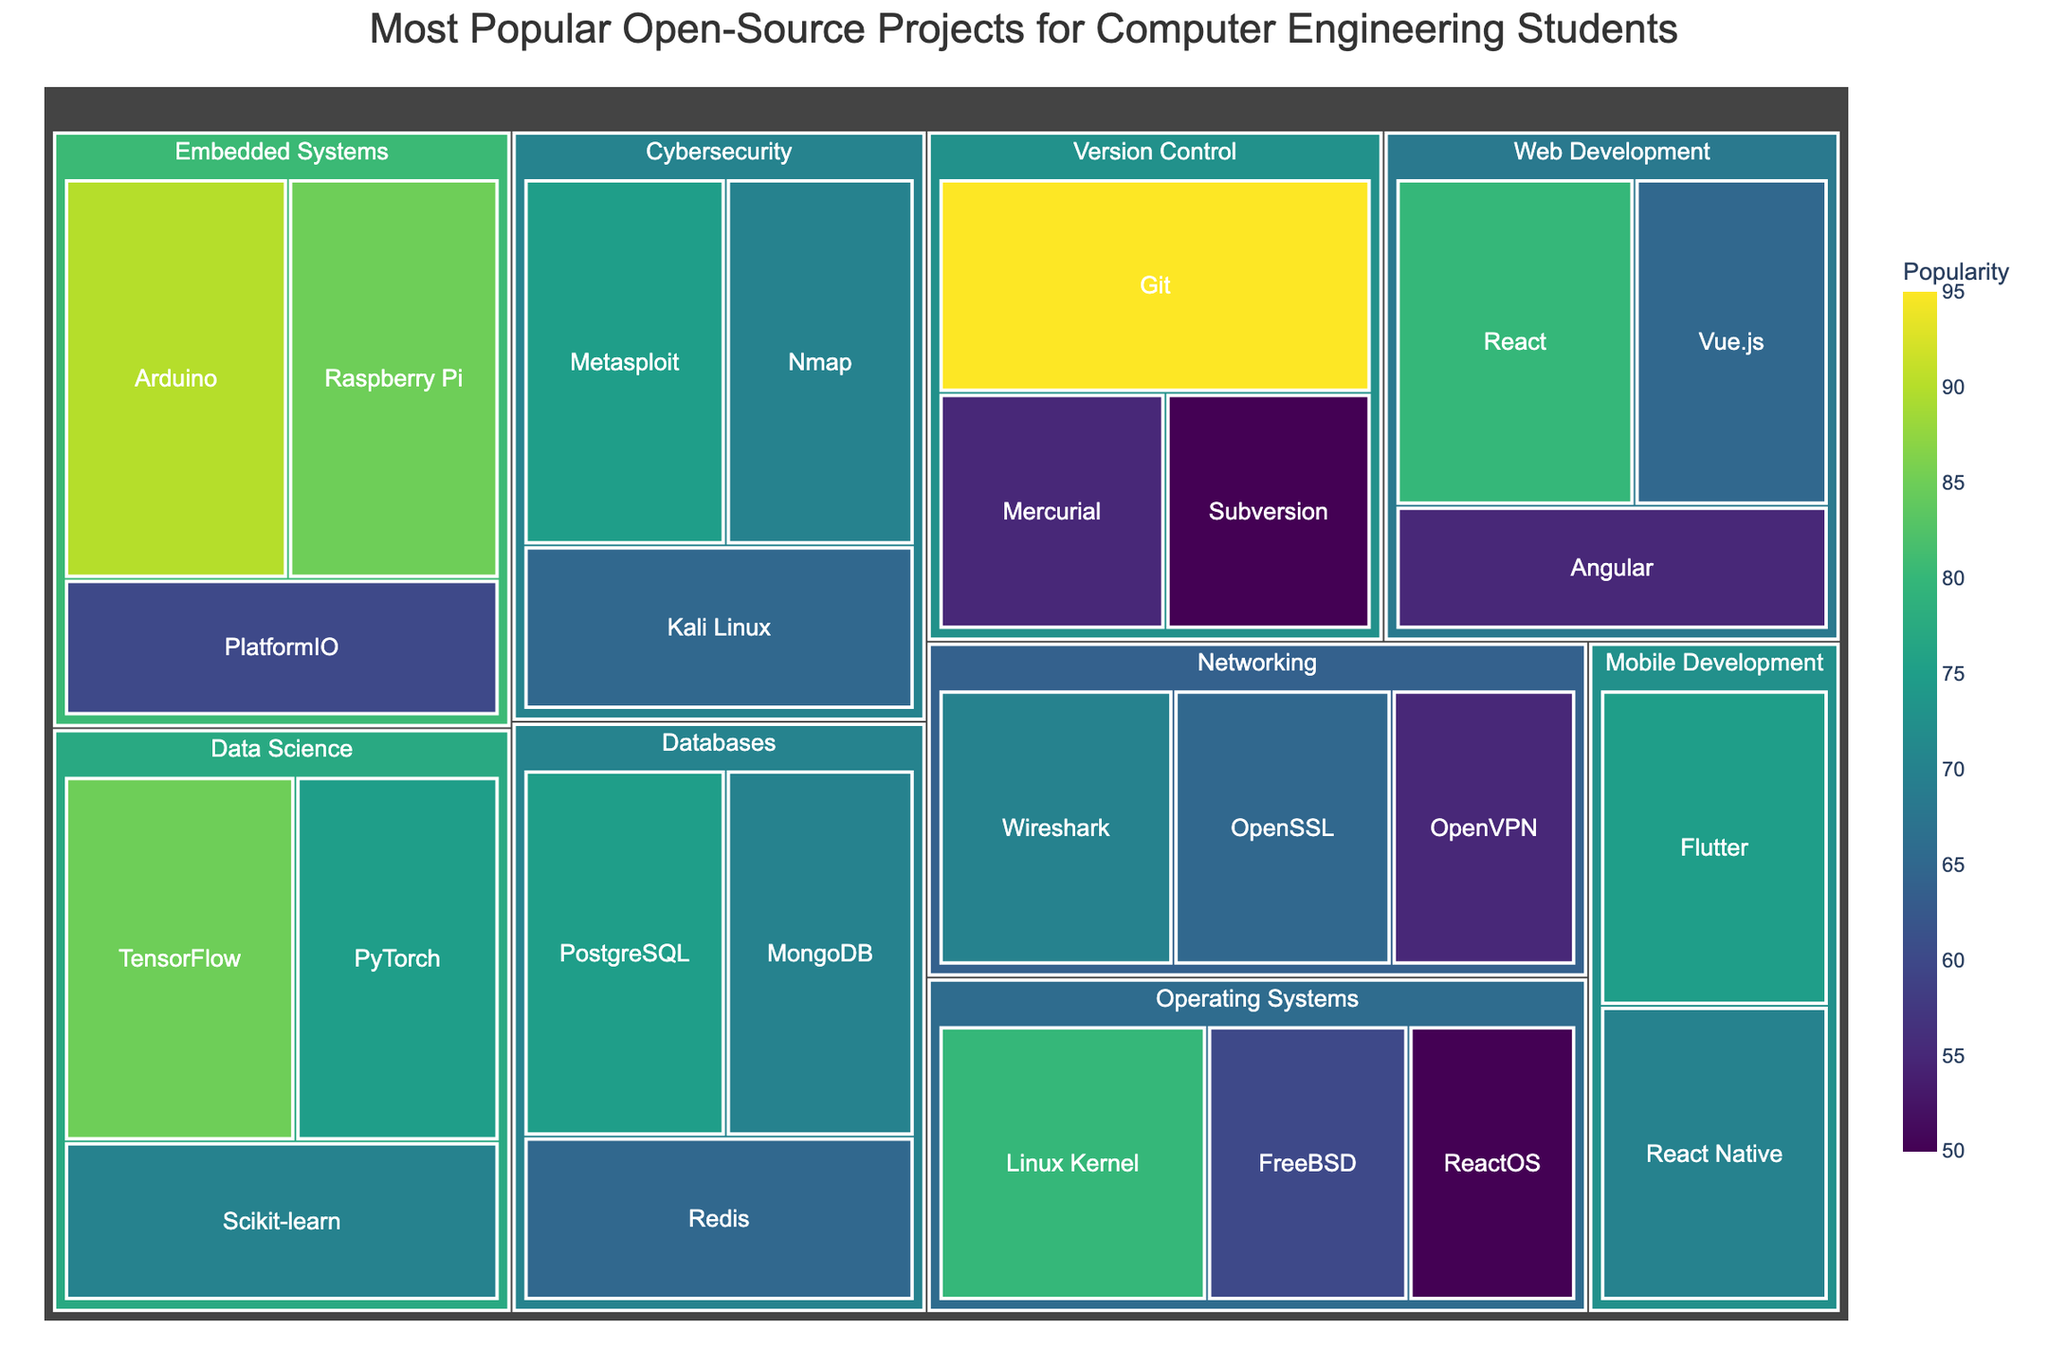What's the most popular project in the 'Web Development' category? The 'Web Development' category contains React, Vue.js, and Angular. By checking their popularity values, React has the highest popularity with a value of 80.
Answer: React Compare the popularity of TensorFlow and PyTorch in the 'Data Science' category. Which one is more popular and by how much? In the 'Data Science' category, TensorFlow has a popularity of 85 and PyTorch has a popularity of 75. TensorFlow is more popular by 10 points.
Answer: TensorFlow by 10 points Identify the least popular project in the 'Version Control' category and provide its popularity value. The 'Version Control' category includes Git, Mercurial, and Subversion. By examining their popularity values, Subversion has the lowest with a value of 50.
Answer: Subversion, 50 What is the combined popularity of 'React Native' and 'Kali Linux'? React Native has a popularity of 70 and Kali Linux has a popularity of 65. Their combined popularity is 70 + 65 = 135.
Answer: 135 How does the popularity of the Linux Kernel compare to Flutter in their respective categories? The Linux Kernel in the 'Operating Systems' category has a popularity of 80, and Flutter in the 'Mobile Development' category has a popularity of 75. The Linux Kernel is more popular than Flutter by 5 points.
Answer: Linux Kernel by 5 points What's the median popularity value for the 'Networking' projects? The 'Networking' projects are Wireshark (70), OpenSSL (65), and OpenVPN (55). To find the median, list the values in order: 55, 65, 70. The median value is the middle one, which is 65.
Answer: 65 How many projects in total are displayed in the treemap? Counting the projects listed in all categories, there are a total of 23 projects.
Answer: 23 Which project in the 'Embedded Systems' category has the highest popularity? In the 'Embedded Systems' category, Arduino, Raspberry Pi, and PlatformIO are listed. Arduino has the highest popularity value of 90.
Answer: Arduino 